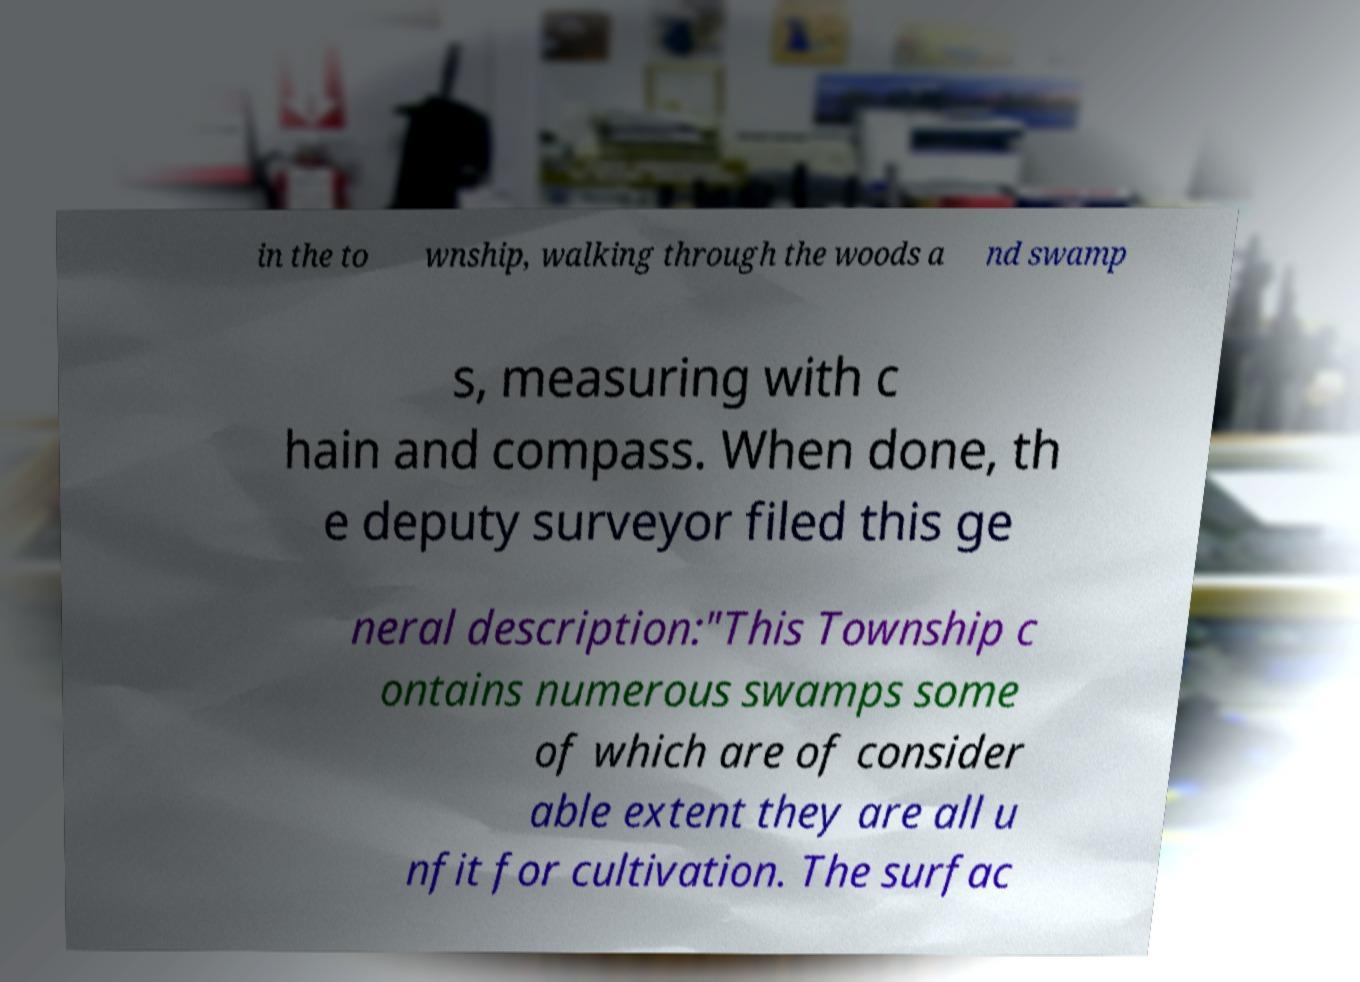For documentation purposes, I need the text within this image transcribed. Could you provide that? in the to wnship, walking through the woods a nd swamp s, measuring with c hain and compass. When done, th e deputy surveyor filed this ge neral description:"This Township c ontains numerous swamps some of which are of consider able extent they are all u nfit for cultivation. The surfac 